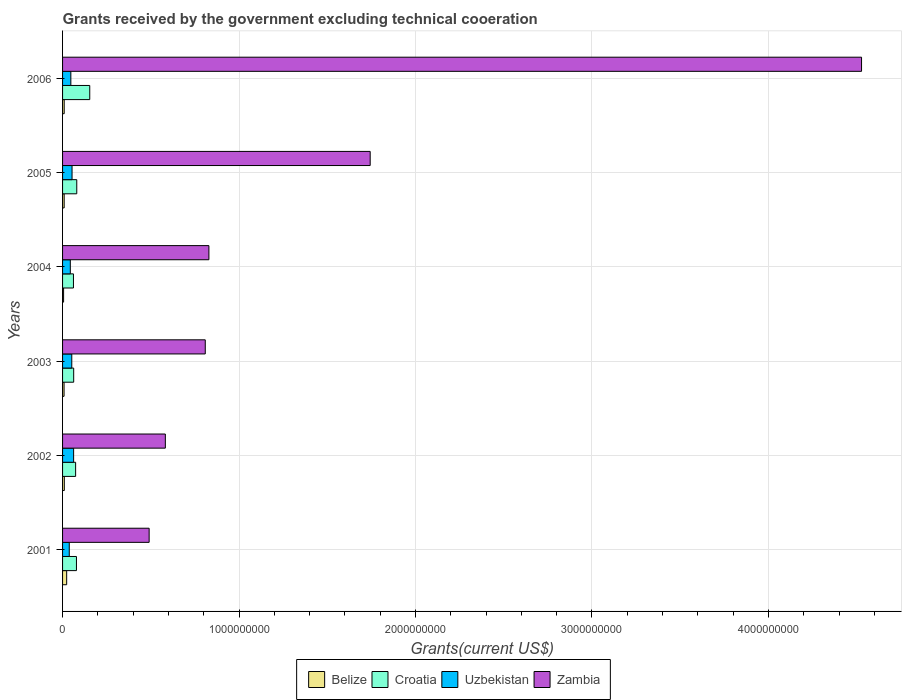In how many cases, is the number of bars for a given year not equal to the number of legend labels?
Your answer should be very brief. 0. What is the total grants received by the government in Belize in 2004?
Your response must be concise. 5.80e+06. Across all years, what is the maximum total grants received by the government in Croatia?
Your response must be concise. 1.54e+08. Across all years, what is the minimum total grants received by the government in Uzbekistan?
Offer a very short reply. 3.80e+07. What is the total total grants received by the government in Belize in the graph?
Offer a very short reply. 6.58e+07. What is the difference between the total grants received by the government in Croatia in 2004 and that in 2005?
Provide a short and direct response. -1.88e+07. What is the difference between the total grants received by the government in Uzbekistan in 2004 and the total grants received by the government in Croatia in 2005?
Make the answer very short. -3.65e+07. What is the average total grants received by the government in Uzbekistan per year?
Your answer should be very brief. 4.96e+07. In the year 2001, what is the difference between the total grants received by the government in Belize and total grants received by the government in Croatia?
Ensure brevity in your answer.  -5.54e+07. In how many years, is the total grants received by the government in Belize greater than 4200000000 US$?
Provide a short and direct response. 0. What is the ratio of the total grants received by the government in Uzbekistan in 2004 to that in 2005?
Your response must be concise. 0.82. Is the total grants received by the government in Uzbekistan in 2001 less than that in 2003?
Provide a short and direct response. Yes. What is the difference between the highest and the second highest total grants received by the government in Croatia?
Ensure brevity in your answer.  7.36e+07. What is the difference between the highest and the lowest total grants received by the government in Croatia?
Provide a succinct answer. 9.24e+07. Is it the case that in every year, the sum of the total grants received by the government in Uzbekistan and total grants received by the government in Zambia is greater than the sum of total grants received by the government in Croatia and total grants received by the government in Belize?
Make the answer very short. Yes. What does the 3rd bar from the top in 2006 represents?
Provide a short and direct response. Croatia. What does the 3rd bar from the bottom in 2006 represents?
Make the answer very short. Uzbekistan. Is it the case that in every year, the sum of the total grants received by the government in Croatia and total grants received by the government in Uzbekistan is greater than the total grants received by the government in Belize?
Offer a terse response. Yes. How many bars are there?
Keep it short and to the point. 24. Are all the bars in the graph horizontal?
Keep it short and to the point. Yes. What is the difference between two consecutive major ticks on the X-axis?
Keep it short and to the point. 1.00e+09. Does the graph contain any zero values?
Provide a succinct answer. No. Does the graph contain grids?
Keep it short and to the point. Yes. How many legend labels are there?
Make the answer very short. 4. How are the legend labels stacked?
Your answer should be compact. Horizontal. What is the title of the graph?
Ensure brevity in your answer.  Grants received by the government excluding technical cooeration. Does "Gambia, The" appear as one of the legend labels in the graph?
Offer a terse response. No. What is the label or title of the X-axis?
Give a very brief answer. Grants(current US$). What is the Grants(current US$) of Belize in 2001?
Ensure brevity in your answer.  2.33e+07. What is the Grants(current US$) in Croatia in 2001?
Your response must be concise. 7.87e+07. What is the Grants(current US$) in Uzbekistan in 2001?
Keep it short and to the point. 3.80e+07. What is the Grants(current US$) of Zambia in 2001?
Offer a very short reply. 4.91e+08. What is the Grants(current US$) of Belize in 2002?
Make the answer very short. 9.91e+06. What is the Grants(current US$) of Croatia in 2002?
Provide a short and direct response. 7.40e+07. What is the Grants(current US$) of Uzbekistan in 2002?
Your answer should be compact. 6.26e+07. What is the Grants(current US$) of Zambia in 2002?
Your answer should be very brief. 5.82e+08. What is the Grants(current US$) in Belize in 2003?
Provide a short and direct response. 8.45e+06. What is the Grants(current US$) of Croatia in 2003?
Give a very brief answer. 6.30e+07. What is the Grants(current US$) of Uzbekistan in 2003?
Offer a very short reply. 5.22e+07. What is the Grants(current US$) in Zambia in 2003?
Provide a short and direct response. 8.09e+08. What is the Grants(current US$) of Belize in 2004?
Provide a succinct answer. 5.80e+06. What is the Grants(current US$) in Croatia in 2004?
Give a very brief answer. 6.17e+07. What is the Grants(current US$) of Uzbekistan in 2004?
Offer a very short reply. 4.39e+07. What is the Grants(current US$) in Zambia in 2004?
Provide a succinct answer. 8.29e+08. What is the Grants(current US$) of Belize in 2005?
Provide a short and direct response. 9.09e+06. What is the Grants(current US$) of Croatia in 2005?
Provide a short and direct response. 8.04e+07. What is the Grants(current US$) in Uzbekistan in 2005?
Provide a short and direct response. 5.37e+07. What is the Grants(current US$) in Zambia in 2005?
Your response must be concise. 1.74e+09. What is the Grants(current US$) in Belize in 2006?
Make the answer very short. 9.27e+06. What is the Grants(current US$) of Croatia in 2006?
Give a very brief answer. 1.54e+08. What is the Grants(current US$) of Uzbekistan in 2006?
Your response must be concise. 4.69e+07. What is the Grants(current US$) of Zambia in 2006?
Offer a very short reply. 4.53e+09. Across all years, what is the maximum Grants(current US$) in Belize?
Offer a terse response. 2.33e+07. Across all years, what is the maximum Grants(current US$) of Croatia?
Keep it short and to the point. 1.54e+08. Across all years, what is the maximum Grants(current US$) in Uzbekistan?
Keep it short and to the point. 6.26e+07. Across all years, what is the maximum Grants(current US$) of Zambia?
Your response must be concise. 4.53e+09. Across all years, what is the minimum Grants(current US$) of Belize?
Provide a succinct answer. 5.80e+06. Across all years, what is the minimum Grants(current US$) of Croatia?
Ensure brevity in your answer.  6.17e+07. Across all years, what is the minimum Grants(current US$) of Uzbekistan?
Your answer should be compact. 3.80e+07. Across all years, what is the minimum Grants(current US$) of Zambia?
Ensure brevity in your answer.  4.91e+08. What is the total Grants(current US$) of Belize in the graph?
Your answer should be very brief. 6.58e+07. What is the total Grants(current US$) of Croatia in the graph?
Ensure brevity in your answer.  5.12e+08. What is the total Grants(current US$) in Uzbekistan in the graph?
Your answer should be compact. 2.97e+08. What is the total Grants(current US$) of Zambia in the graph?
Offer a terse response. 8.98e+09. What is the difference between the Grants(current US$) of Belize in 2001 and that in 2002?
Your answer should be very brief. 1.34e+07. What is the difference between the Grants(current US$) in Croatia in 2001 and that in 2002?
Offer a terse response. 4.76e+06. What is the difference between the Grants(current US$) in Uzbekistan in 2001 and that in 2002?
Make the answer very short. -2.46e+07. What is the difference between the Grants(current US$) of Zambia in 2001 and that in 2002?
Offer a very short reply. -9.18e+07. What is the difference between the Grants(current US$) of Belize in 2001 and that in 2003?
Offer a terse response. 1.48e+07. What is the difference between the Grants(current US$) in Croatia in 2001 and that in 2003?
Your response must be concise. 1.58e+07. What is the difference between the Grants(current US$) in Uzbekistan in 2001 and that in 2003?
Provide a succinct answer. -1.42e+07. What is the difference between the Grants(current US$) of Zambia in 2001 and that in 2003?
Your answer should be very brief. -3.18e+08. What is the difference between the Grants(current US$) of Belize in 2001 and that in 2004?
Make the answer very short. 1.75e+07. What is the difference between the Grants(current US$) of Croatia in 2001 and that in 2004?
Ensure brevity in your answer.  1.71e+07. What is the difference between the Grants(current US$) of Uzbekistan in 2001 and that in 2004?
Keep it short and to the point. -5.89e+06. What is the difference between the Grants(current US$) of Zambia in 2001 and that in 2004?
Your response must be concise. -3.39e+08. What is the difference between the Grants(current US$) in Belize in 2001 and that in 2005?
Ensure brevity in your answer.  1.42e+07. What is the difference between the Grants(current US$) of Croatia in 2001 and that in 2005?
Your response must be concise. -1.70e+06. What is the difference between the Grants(current US$) in Uzbekistan in 2001 and that in 2005?
Give a very brief answer. -1.57e+07. What is the difference between the Grants(current US$) in Zambia in 2001 and that in 2005?
Offer a very short reply. -1.25e+09. What is the difference between the Grants(current US$) of Belize in 2001 and that in 2006?
Offer a very short reply. 1.40e+07. What is the difference between the Grants(current US$) in Croatia in 2001 and that in 2006?
Provide a short and direct response. -7.53e+07. What is the difference between the Grants(current US$) of Uzbekistan in 2001 and that in 2006?
Make the answer very short. -8.90e+06. What is the difference between the Grants(current US$) in Zambia in 2001 and that in 2006?
Ensure brevity in your answer.  -4.04e+09. What is the difference between the Grants(current US$) in Belize in 2002 and that in 2003?
Make the answer very short. 1.46e+06. What is the difference between the Grants(current US$) in Croatia in 2002 and that in 2003?
Your answer should be compact. 1.10e+07. What is the difference between the Grants(current US$) in Uzbekistan in 2002 and that in 2003?
Your answer should be very brief. 1.04e+07. What is the difference between the Grants(current US$) of Zambia in 2002 and that in 2003?
Offer a very short reply. -2.26e+08. What is the difference between the Grants(current US$) of Belize in 2002 and that in 2004?
Your answer should be compact. 4.11e+06. What is the difference between the Grants(current US$) of Croatia in 2002 and that in 2004?
Keep it short and to the point. 1.23e+07. What is the difference between the Grants(current US$) of Uzbekistan in 2002 and that in 2004?
Provide a succinct answer. 1.88e+07. What is the difference between the Grants(current US$) in Zambia in 2002 and that in 2004?
Your answer should be compact. -2.47e+08. What is the difference between the Grants(current US$) in Belize in 2002 and that in 2005?
Provide a short and direct response. 8.20e+05. What is the difference between the Grants(current US$) in Croatia in 2002 and that in 2005?
Your answer should be compact. -6.46e+06. What is the difference between the Grants(current US$) in Uzbekistan in 2002 and that in 2005?
Your answer should be very brief. 8.91e+06. What is the difference between the Grants(current US$) in Zambia in 2002 and that in 2005?
Give a very brief answer. -1.16e+09. What is the difference between the Grants(current US$) in Belize in 2002 and that in 2006?
Provide a short and direct response. 6.40e+05. What is the difference between the Grants(current US$) in Croatia in 2002 and that in 2006?
Give a very brief answer. -8.01e+07. What is the difference between the Grants(current US$) in Uzbekistan in 2002 and that in 2006?
Offer a very short reply. 1.57e+07. What is the difference between the Grants(current US$) in Zambia in 2002 and that in 2006?
Give a very brief answer. -3.94e+09. What is the difference between the Grants(current US$) in Belize in 2003 and that in 2004?
Your response must be concise. 2.65e+06. What is the difference between the Grants(current US$) of Croatia in 2003 and that in 2004?
Your answer should be compact. 1.32e+06. What is the difference between the Grants(current US$) in Uzbekistan in 2003 and that in 2004?
Offer a very short reply. 8.30e+06. What is the difference between the Grants(current US$) of Zambia in 2003 and that in 2004?
Ensure brevity in your answer.  -2.06e+07. What is the difference between the Grants(current US$) of Belize in 2003 and that in 2005?
Ensure brevity in your answer.  -6.40e+05. What is the difference between the Grants(current US$) of Croatia in 2003 and that in 2005?
Provide a short and direct response. -1.74e+07. What is the difference between the Grants(current US$) in Uzbekistan in 2003 and that in 2005?
Your answer should be very brief. -1.54e+06. What is the difference between the Grants(current US$) of Zambia in 2003 and that in 2005?
Give a very brief answer. -9.34e+08. What is the difference between the Grants(current US$) in Belize in 2003 and that in 2006?
Provide a short and direct response. -8.20e+05. What is the difference between the Grants(current US$) in Croatia in 2003 and that in 2006?
Your answer should be very brief. -9.11e+07. What is the difference between the Grants(current US$) in Uzbekistan in 2003 and that in 2006?
Give a very brief answer. 5.29e+06. What is the difference between the Grants(current US$) in Zambia in 2003 and that in 2006?
Give a very brief answer. -3.72e+09. What is the difference between the Grants(current US$) in Belize in 2004 and that in 2005?
Make the answer very short. -3.29e+06. What is the difference between the Grants(current US$) of Croatia in 2004 and that in 2005?
Give a very brief answer. -1.88e+07. What is the difference between the Grants(current US$) of Uzbekistan in 2004 and that in 2005?
Provide a short and direct response. -9.84e+06. What is the difference between the Grants(current US$) of Zambia in 2004 and that in 2005?
Offer a terse response. -9.14e+08. What is the difference between the Grants(current US$) of Belize in 2004 and that in 2006?
Provide a short and direct response. -3.47e+06. What is the difference between the Grants(current US$) of Croatia in 2004 and that in 2006?
Ensure brevity in your answer.  -9.24e+07. What is the difference between the Grants(current US$) in Uzbekistan in 2004 and that in 2006?
Your answer should be very brief. -3.01e+06. What is the difference between the Grants(current US$) in Zambia in 2004 and that in 2006?
Ensure brevity in your answer.  -3.70e+09. What is the difference between the Grants(current US$) of Belize in 2005 and that in 2006?
Give a very brief answer. -1.80e+05. What is the difference between the Grants(current US$) of Croatia in 2005 and that in 2006?
Offer a terse response. -7.36e+07. What is the difference between the Grants(current US$) of Uzbekistan in 2005 and that in 2006?
Provide a short and direct response. 6.83e+06. What is the difference between the Grants(current US$) in Zambia in 2005 and that in 2006?
Make the answer very short. -2.78e+09. What is the difference between the Grants(current US$) of Belize in 2001 and the Grants(current US$) of Croatia in 2002?
Ensure brevity in your answer.  -5.07e+07. What is the difference between the Grants(current US$) of Belize in 2001 and the Grants(current US$) of Uzbekistan in 2002?
Give a very brief answer. -3.94e+07. What is the difference between the Grants(current US$) in Belize in 2001 and the Grants(current US$) in Zambia in 2002?
Your answer should be very brief. -5.59e+08. What is the difference between the Grants(current US$) of Croatia in 2001 and the Grants(current US$) of Uzbekistan in 2002?
Your answer should be compact. 1.61e+07. What is the difference between the Grants(current US$) of Croatia in 2001 and the Grants(current US$) of Zambia in 2002?
Your answer should be compact. -5.04e+08. What is the difference between the Grants(current US$) of Uzbekistan in 2001 and the Grants(current US$) of Zambia in 2002?
Offer a very short reply. -5.44e+08. What is the difference between the Grants(current US$) in Belize in 2001 and the Grants(current US$) in Croatia in 2003?
Make the answer very short. -3.97e+07. What is the difference between the Grants(current US$) of Belize in 2001 and the Grants(current US$) of Uzbekistan in 2003?
Give a very brief answer. -2.89e+07. What is the difference between the Grants(current US$) of Belize in 2001 and the Grants(current US$) of Zambia in 2003?
Keep it short and to the point. -7.85e+08. What is the difference between the Grants(current US$) of Croatia in 2001 and the Grants(current US$) of Uzbekistan in 2003?
Your response must be concise. 2.65e+07. What is the difference between the Grants(current US$) of Croatia in 2001 and the Grants(current US$) of Zambia in 2003?
Provide a succinct answer. -7.30e+08. What is the difference between the Grants(current US$) of Uzbekistan in 2001 and the Grants(current US$) of Zambia in 2003?
Your answer should be compact. -7.71e+08. What is the difference between the Grants(current US$) in Belize in 2001 and the Grants(current US$) in Croatia in 2004?
Make the answer very short. -3.84e+07. What is the difference between the Grants(current US$) of Belize in 2001 and the Grants(current US$) of Uzbekistan in 2004?
Your answer should be very brief. -2.06e+07. What is the difference between the Grants(current US$) in Belize in 2001 and the Grants(current US$) in Zambia in 2004?
Make the answer very short. -8.06e+08. What is the difference between the Grants(current US$) in Croatia in 2001 and the Grants(current US$) in Uzbekistan in 2004?
Offer a terse response. 3.48e+07. What is the difference between the Grants(current US$) in Croatia in 2001 and the Grants(current US$) in Zambia in 2004?
Your answer should be very brief. -7.50e+08. What is the difference between the Grants(current US$) in Uzbekistan in 2001 and the Grants(current US$) in Zambia in 2004?
Your answer should be compact. -7.91e+08. What is the difference between the Grants(current US$) of Belize in 2001 and the Grants(current US$) of Croatia in 2005?
Keep it short and to the point. -5.71e+07. What is the difference between the Grants(current US$) in Belize in 2001 and the Grants(current US$) in Uzbekistan in 2005?
Make the answer very short. -3.04e+07. What is the difference between the Grants(current US$) in Belize in 2001 and the Grants(current US$) in Zambia in 2005?
Offer a terse response. -1.72e+09. What is the difference between the Grants(current US$) in Croatia in 2001 and the Grants(current US$) in Uzbekistan in 2005?
Offer a very short reply. 2.50e+07. What is the difference between the Grants(current US$) in Croatia in 2001 and the Grants(current US$) in Zambia in 2005?
Make the answer very short. -1.66e+09. What is the difference between the Grants(current US$) in Uzbekistan in 2001 and the Grants(current US$) in Zambia in 2005?
Ensure brevity in your answer.  -1.71e+09. What is the difference between the Grants(current US$) of Belize in 2001 and the Grants(current US$) of Croatia in 2006?
Offer a very short reply. -1.31e+08. What is the difference between the Grants(current US$) of Belize in 2001 and the Grants(current US$) of Uzbekistan in 2006?
Ensure brevity in your answer.  -2.36e+07. What is the difference between the Grants(current US$) of Belize in 2001 and the Grants(current US$) of Zambia in 2006?
Ensure brevity in your answer.  -4.50e+09. What is the difference between the Grants(current US$) of Croatia in 2001 and the Grants(current US$) of Uzbekistan in 2006?
Offer a very short reply. 3.18e+07. What is the difference between the Grants(current US$) in Croatia in 2001 and the Grants(current US$) in Zambia in 2006?
Provide a short and direct response. -4.45e+09. What is the difference between the Grants(current US$) of Uzbekistan in 2001 and the Grants(current US$) of Zambia in 2006?
Ensure brevity in your answer.  -4.49e+09. What is the difference between the Grants(current US$) of Belize in 2002 and the Grants(current US$) of Croatia in 2003?
Offer a terse response. -5.31e+07. What is the difference between the Grants(current US$) in Belize in 2002 and the Grants(current US$) in Uzbekistan in 2003?
Offer a very short reply. -4.23e+07. What is the difference between the Grants(current US$) of Belize in 2002 and the Grants(current US$) of Zambia in 2003?
Ensure brevity in your answer.  -7.99e+08. What is the difference between the Grants(current US$) in Croatia in 2002 and the Grants(current US$) in Uzbekistan in 2003?
Offer a very short reply. 2.18e+07. What is the difference between the Grants(current US$) in Croatia in 2002 and the Grants(current US$) in Zambia in 2003?
Make the answer very short. -7.35e+08. What is the difference between the Grants(current US$) of Uzbekistan in 2002 and the Grants(current US$) of Zambia in 2003?
Your answer should be very brief. -7.46e+08. What is the difference between the Grants(current US$) in Belize in 2002 and the Grants(current US$) in Croatia in 2004?
Provide a succinct answer. -5.18e+07. What is the difference between the Grants(current US$) of Belize in 2002 and the Grants(current US$) of Uzbekistan in 2004?
Your answer should be very brief. -3.40e+07. What is the difference between the Grants(current US$) in Belize in 2002 and the Grants(current US$) in Zambia in 2004?
Keep it short and to the point. -8.19e+08. What is the difference between the Grants(current US$) in Croatia in 2002 and the Grants(current US$) in Uzbekistan in 2004?
Offer a terse response. 3.01e+07. What is the difference between the Grants(current US$) in Croatia in 2002 and the Grants(current US$) in Zambia in 2004?
Make the answer very short. -7.55e+08. What is the difference between the Grants(current US$) in Uzbekistan in 2002 and the Grants(current US$) in Zambia in 2004?
Your answer should be very brief. -7.67e+08. What is the difference between the Grants(current US$) in Belize in 2002 and the Grants(current US$) in Croatia in 2005?
Your answer should be very brief. -7.05e+07. What is the difference between the Grants(current US$) in Belize in 2002 and the Grants(current US$) in Uzbekistan in 2005?
Offer a very short reply. -4.38e+07. What is the difference between the Grants(current US$) of Belize in 2002 and the Grants(current US$) of Zambia in 2005?
Your answer should be very brief. -1.73e+09. What is the difference between the Grants(current US$) in Croatia in 2002 and the Grants(current US$) in Uzbekistan in 2005?
Your answer should be very brief. 2.02e+07. What is the difference between the Grants(current US$) of Croatia in 2002 and the Grants(current US$) of Zambia in 2005?
Your answer should be very brief. -1.67e+09. What is the difference between the Grants(current US$) of Uzbekistan in 2002 and the Grants(current US$) of Zambia in 2005?
Offer a terse response. -1.68e+09. What is the difference between the Grants(current US$) in Belize in 2002 and the Grants(current US$) in Croatia in 2006?
Your response must be concise. -1.44e+08. What is the difference between the Grants(current US$) of Belize in 2002 and the Grants(current US$) of Uzbekistan in 2006?
Provide a succinct answer. -3.70e+07. What is the difference between the Grants(current US$) of Belize in 2002 and the Grants(current US$) of Zambia in 2006?
Provide a succinct answer. -4.52e+09. What is the difference between the Grants(current US$) in Croatia in 2002 and the Grants(current US$) in Uzbekistan in 2006?
Your answer should be very brief. 2.71e+07. What is the difference between the Grants(current US$) in Croatia in 2002 and the Grants(current US$) in Zambia in 2006?
Give a very brief answer. -4.45e+09. What is the difference between the Grants(current US$) in Uzbekistan in 2002 and the Grants(current US$) in Zambia in 2006?
Offer a very short reply. -4.46e+09. What is the difference between the Grants(current US$) of Belize in 2003 and the Grants(current US$) of Croatia in 2004?
Your response must be concise. -5.32e+07. What is the difference between the Grants(current US$) in Belize in 2003 and the Grants(current US$) in Uzbekistan in 2004?
Provide a short and direct response. -3.54e+07. What is the difference between the Grants(current US$) of Belize in 2003 and the Grants(current US$) of Zambia in 2004?
Offer a very short reply. -8.21e+08. What is the difference between the Grants(current US$) of Croatia in 2003 and the Grants(current US$) of Uzbekistan in 2004?
Give a very brief answer. 1.91e+07. What is the difference between the Grants(current US$) in Croatia in 2003 and the Grants(current US$) in Zambia in 2004?
Make the answer very short. -7.66e+08. What is the difference between the Grants(current US$) in Uzbekistan in 2003 and the Grants(current US$) in Zambia in 2004?
Offer a very short reply. -7.77e+08. What is the difference between the Grants(current US$) in Belize in 2003 and the Grants(current US$) in Croatia in 2005?
Your answer should be very brief. -7.20e+07. What is the difference between the Grants(current US$) in Belize in 2003 and the Grants(current US$) in Uzbekistan in 2005?
Make the answer very short. -4.53e+07. What is the difference between the Grants(current US$) in Belize in 2003 and the Grants(current US$) in Zambia in 2005?
Your answer should be very brief. -1.73e+09. What is the difference between the Grants(current US$) of Croatia in 2003 and the Grants(current US$) of Uzbekistan in 2005?
Your response must be concise. 9.25e+06. What is the difference between the Grants(current US$) in Croatia in 2003 and the Grants(current US$) in Zambia in 2005?
Give a very brief answer. -1.68e+09. What is the difference between the Grants(current US$) of Uzbekistan in 2003 and the Grants(current US$) of Zambia in 2005?
Keep it short and to the point. -1.69e+09. What is the difference between the Grants(current US$) of Belize in 2003 and the Grants(current US$) of Croatia in 2006?
Make the answer very short. -1.46e+08. What is the difference between the Grants(current US$) of Belize in 2003 and the Grants(current US$) of Uzbekistan in 2006?
Your answer should be very brief. -3.84e+07. What is the difference between the Grants(current US$) of Belize in 2003 and the Grants(current US$) of Zambia in 2006?
Keep it short and to the point. -4.52e+09. What is the difference between the Grants(current US$) of Croatia in 2003 and the Grants(current US$) of Uzbekistan in 2006?
Your response must be concise. 1.61e+07. What is the difference between the Grants(current US$) in Croatia in 2003 and the Grants(current US$) in Zambia in 2006?
Offer a terse response. -4.46e+09. What is the difference between the Grants(current US$) in Uzbekistan in 2003 and the Grants(current US$) in Zambia in 2006?
Make the answer very short. -4.48e+09. What is the difference between the Grants(current US$) of Belize in 2004 and the Grants(current US$) of Croatia in 2005?
Offer a very short reply. -7.46e+07. What is the difference between the Grants(current US$) of Belize in 2004 and the Grants(current US$) of Uzbekistan in 2005?
Provide a short and direct response. -4.79e+07. What is the difference between the Grants(current US$) in Belize in 2004 and the Grants(current US$) in Zambia in 2005?
Ensure brevity in your answer.  -1.74e+09. What is the difference between the Grants(current US$) of Croatia in 2004 and the Grants(current US$) of Uzbekistan in 2005?
Your answer should be compact. 7.93e+06. What is the difference between the Grants(current US$) in Croatia in 2004 and the Grants(current US$) in Zambia in 2005?
Provide a short and direct response. -1.68e+09. What is the difference between the Grants(current US$) in Uzbekistan in 2004 and the Grants(current US$) in Zambia in 2005?
Your response must be concise. -1.70e+09. What is the difference between the Grants(current US$) of Belize in 2004 and the Grants(current US$) of Croatia in 2006?
Give a very brief answer. -1.48e+08. What is the difference between the Grants(current US$) of Belize in 2004 and the Grants(current US$) of Uzbekistan in 2006?
Offer a very short reply. -4.11e+07. What is the difference between the Grants(current US$) in Belize in 2004 and the Grants(current US$) in Zambia in 2006?
Your answer should be compact. -4.52e+09. What is the difference between the Grants(current US$) in Croatia in 2004 and the Grants(current US$) in Uzbekistan in 2006?
Ensure brevity in your answer.  1.48e+07. What is the difference between the Grants(current US$) of Croatia in 2004 and the Grants(current US$) of Zambia in 2006?
Your answer should be compact. -4.47e+09. What is the difference between the Grants(current US$) of Uzbekistan in 2004 and the Grants(current US$) of Zambia in 2006?
Offer a very short reply. -4.48e+09. What is the difference between the Grants(current US$) of Belize in 2005 and the Grants(current US$) of Croatia in 2006?
Make the answer very short. -1.45e+08. What is the difference between the Grants(current US$) of Belize in 2005 and the Grants(current US$) of Uzbekistan in 2006?
Ensure brevity in your answer.  -3.78e+07. What is the difference between the Grants(current US$) in Belize in 2005 and the Grants(current US$) in Zambia in 2006?
Provide a succinct answer. -4.52e+09. What is the difference between the Grants(current US$) of Croatia in 2005 and the Grants(current US$) of Uzbekistan in 2006?
Provide a short and direct response. 3.35e+07. What is the difference between the Grants(current US$) in Croatia in 2005 and the Grants(current US$) in Zambia in 2006?
Give a very brief answer. -4.45e+09. What is the difference between the Grants(current US$) in Uzbekistan in 2005 and the Grants(current US$) in Zambia in 2006?
Offer a terse response. -4.47e+09. What is the average Grants(current US$) in Belize per year?
Give a very brief answer. 1.10e+07. What is the average Grants(current US$) of Croatia per year?
Provide a succinct answer. 8.53e+07. What is the average Grants(current US$) of Uzbekistan per year?
Offer a terse response. 4.96e+07. What is the average Grants(current US$) in Zambia per year?
Offer a terse response. 1.50e+09. In the year 2001, what is the difference between the Grants(current US$) in Belize and Grants(current US$) in Croatia?
Provide a succinct answer. -5.54e+07. In the year 2001, what is the difference between the Grants(current US$) in Belize and Grants(current US$) in Uzbekistan?
Offer a terse response. -1.47e+07. In the year 2001, what is the difference between the Grants(current US$) in Belize and Grants(current US$) in Zambia?
Keep it short and to the point. -4.67e+08. In the year 2001, what is the difference between the Grants(current US$) in Croatia and Grants(current US$) in Uzbekistan?
Your response must be concise. 4.07e+07. In the year 2001, what is the difference between the Grants(current US$) in Croatia and Grants(current US$) in Zambia?
Make the answer very short. -4.12e+08. In the year 2001, what is the difference between the Grants(current US$) of Uzbekistan and Grants(current US$) of Zambia?
Your answer should be very brief. -4.53e+08. In the year 2002, what is the difference between the Grants(current US$) in Belize and Grants(current US$) in Croatia?
Make the answer very short. -6.41e+07. In the year 2002, what is the difference between the Grants(current US$) of Belize and Grants(current US$) of Uzbekistan?
Make the answer very short. -5.27e+07. In the year 2002, what is the difference between the Grants(current US$) of Belize and Grants(current US$) of Zambia?
Give a very brief answer. -5.73e+08. In the year 2002, what is the difference between the Grants(current US$) of Croatia and Grants(current US$) of Uzbekistan?
Your answer should be very brief. 1.13e+07. In the year 2002, what is the difference between the Grants(current US$) of Croatia and Grants(current US$) of Zambia?
Provide a short and direct response. -5.08e+08. In the year 2002, what is the difference between the Grants(current US$) of Uzbekistan and Grants(current US$) of Zambia?
Give a very brief answer. -5.20e+08. In the year 2003, what is the difference between the Grants(current US$) of Belize and Grants(current US$) of Croatia?
Your answer should be compact. -5.45e+07. In the year 2003, what is the difference between the Grants(current US$) in Belize and Grants(current US$) in Uzbekistan?
Your answer should be compact. -4.37e+07. In the year 2003, what is the difference between the Grants(current US$) in Belize and Grants(current US$) in Zambia?
Ensure brevity in your answer.  -8.00e+08. In the year 2003, what is the difference between the Grants(current US$) in Croatia and Grants(current US$) in Uzbekistan?
Your answer should be very brief. 1.08e+07. In the year 2003, what is the difference between the Grants(current US$) of Croatia and Grants(current US$) of Zambia?
Provide a short and direct response. -7.46e+08. In the year 2003, what is the difference between the Grants(current US$) in Uzbekistan and Grants(current US$) in Zambia?
Ensure brevity in your answer.  -7.56e+08. In the year 2004, what is the difference between the Grants(current US$) of Belize and Grants(current US$) of Croatia?
Your answer should be very brief. -5.59e+07. In the year 2004, what is the difference between the Grants(current US$) in Belize and Grants(current US$) in Uzbekistan?
Offer a very short reply. -3.81e+07. In the year 2004, what is the difference between the Grants(current US$) in Belize and Grants(current US$) in Zambia?
Ensure brevity in your answer.  -8.23e+08. In the year 2004, what is the difference between the Grants(current US$) in Croatia and Grants(current US$) in Uzbekistan?
Ensure brevity in your answer.  1.78e+07. In the year 2004, what is the difference between the Grants(current US$) of Croatia and Grants(current US$) of Zambia?
Your answer should be compact. -7.68e+08. In the year 2004, what is the difference between the Grants(current US$) in Uzbekistan and Grants(current US$) in Zambia?
Your answer should be compact. -7.85e+08. In the year 2005, what is the difference between the Grants(current US$) of Belize and Grants(current US$) of Croatia?
Ensure brevity in your answer.  -7.13e+07. In the year 2005, what is the difference between the Grants(current US$) in Belize and Grants(current US$) in Uzbekistan?
Provide a short and direct response. -4.46e+07. In the year 2005, what is the difference between the Grants(current US$) of Belize and Grants(current US$) of Zambia?
Make the answer very short. -1.73e+09. In the year 2005, what is the difference between the Grants(current US$) in Croatia and Grants(current US$) in Uzbekistan?
Your answer should be very brief. 2.67e+07. In the year 2005, what is the difference between the Grants(current US$) in Croatia and Grants(current US$) in Zambia?
Your response must be concise. -1.66e+09. In the year 2005, what is the difference between the Grants(current US$) of Uzbekistan and Grants(current US$) of Zambia?
Your response must be concise. -1.69e+09. In the year 2006, what is the difference between the Grants(current US$) in Belize and Grants(current US$) in Croatia?
Ensure brevity in your answer.  -1.45e+08. In the year 2006, what is the difference between the Grants(current US$) of Belize and Grants(current US$) of Uzbekistan?
Offer a terse response. -3.76e+07. In the year 2006, what is the difference between the Grants(current US$) in Belize and Grants(current US$) in Zambia?
Provide a succinct answer. -4.52e+09. In the year 2006, what is the difference between the Grants(current US$) of Croatia and Grants(current US$) of Uzbekistan?
Make the answer very short. 1.07e+08. In the year 2006, what is the difference between the Grants(current US$) of Croatia and Grants(current US$) of Zambia?
Your answer should be compact. -4.37e+09. In the year 2006, what is the difference between the Grants(current US$) in Uzbekistan and Grants(current US$) in Zambia?
Your answer should be very brief. -4.48e+09. What is the ratio of the Grants(current US$) of Belize in 2001 to that in 2002?
Your answer should be very brief. 2.35. What is the ratio of the Grants(current US$) in Croatia in 2001 to that in 2002?
Give a very brief answer. 1.06. What is the ratio of the Grants(current US$) in Uzbekistan in 2001 to that in 2002?
Give a very brief answer. 0.61. What is the ratio of the Grants(current US$) of Zambia in 2001 to that in 2002?
Make the answer very short. 0.84. What is the ratio of the Grants(current US$) in Belize in 2001 to that in 2003?
Provide a short and direct response. 2.76. What is the ratio of the Grants(current US$) in Croatia in 2001 to that in 2003?
Give a very brief answer. 1.25. What is the ratio of the Grants(current US$) of Uzbekistan in 2001 to that in 2003?
Give a very brief answer. 0.73. What is the ratio of the Grants(current US$) of Zambia in 2001 to that in 2003?
Give a very brief answer. 0.61. What is the ratio of the Grants(current US$) of Belize in 2001 to that in 2004?
Keep it short and to the point. 4.02. What is the ratio of the Grants(current US$) of Croatia in 2001 to that in 2004?
Offer a terse response. 1.28. What is the ratio of the Grants(current US$) in Uzbekistan in 2001 to that in 2004?
Make the answer very short. 0.87. What is the ratio of the Grants(current US$) in Zambia in 2001 to that in 2004?
Your answer should be very brief. 0.59. What is the ratio of the Grants(current US$) in Belize in 2001 to that in 2005?
Keep it short and to the point. 2.56. What is the ratio of the Grants(current US$) of Croatia in 2001 to that in 2005?
Provide a short and direct response. 0.98. What is the ratio of the Grants(current US$) in Uzbekistan in 2001 to that in 2005?
Your answer should be very brief. 0.71. What is the ratio of the Grants(current US$) of Zambia in 2001 to that in 2005?
Your answer should be compact. 0.28. What is the ratio of the Grants(current US$) in Belize in 2001 to that in 2006?
Ensure brevity in your answer.  2.51. What is the ratio of the Grants(current US$) in Croatia in 2001 to that in 2006?
Provide a short and direct response. 0.51. What is the ratio of the Grants(current US$) in Uzbekistan in 2001 to that in 2006?
Offer a terse response. 0.81. What is the ratio of the Grants(current US$) of Zambia in 2001 to that in 2006?
Offer a very short reply. 0.11. What is the ratio of the Grants(current US$) in Belize in 2002 to that in 2003?
Your response must be concise. 1.17. What is the ratio of the Grants(current US$) of Croatia in 2002 to that in 2003?
Your answer should be compact. 1.17. What is the ratio of the Grants(current US$) of Uzbekistan in 2002 to that in 2003?
Your answer should be compact. 1.2. What is the ratio of the Grants(current US$) of Zambia in 2002 to that in 2003?
Ensure brevity in your answer.  0.72. What is the ratio of the Grants(current US$) in Belize in 2002 to that in 2004?
Make the answer very short. 1.71. What is the ratio of the Grants(current US$) of Croatia in 2002 to that in 2004?
Your answer should be compact. 1.2. What is the ratio of the Grants(current US$) of Uzbekistan in 2002 to that in 2004?
Offer a terse response. 1.43. What is the ratio of the Grants(current US$) in Zambia in 2002 to that in 2004?
Your response must be concise. 0.7. What is the ratio of the Grants(current US$) of Belize in 2002 to that in 2005?
Provide a succinct answer. 1.09. What is the ratio of the Grants(current US$) in Croatia in 2002 to that in 2005?
Provide a succinct answer. 0.92. What is the ratio of the Grants(current US$) in Uzbekistan in 2002 to that in 2005?
Your answer should be compact. 1.17. What is the ratio of the Grants(current US$) in Zambia in 2002 to that in 2005?
Provide a short and direct response. 0.33. What is the ratio of the Grants(current US$) of Belize in 2002 to that in 2006?
Keep it short and to the point. 1.07. What is the ratio of the Grants(current US$) of Croatia in 2002 to that in 2006?
Your response must be concise. 0.48. What is the ratio of the Grants(current US$) of Uzbekistan in 2002 to that in 2006?
Offer a terse response. 1.34. What is the ratio of the Grants(current US$) in Zambia in 2002 to that in 2006?
Make the answer very short. 0.13. What is the ratio of the Grants(current US$) of Belize in 2003 to that in 2004?
Keep it short and to the point. 1.46. What is the ratio of the Grants(current US$) in Croatia in 2003 to that in 2004?
Your answer should be compact. 1.02. What is the ratio of the Grants(current US$) in Uzbekistan in 2003 to that in 2004?
Keep it short and to the point. 1.19. What is the ratio of the Grants(current US$) of Zambia in 2003 to that in 2004?
Give a very brief answer. 0.98. What is the ratio of the Grants(current US$) in Belize in 2003 to that in 2005?
Offer a terse response. 0.93. What is the ratio of the Grants(current US$) of Croatia in 2003 to that in 2005?
Keep it short and to the point. 0.78. What is the ratio of the Grants(current US$) of Uzbekistan in 2003 to that in 2005?
Your response must be concise. 0.97. What is the ratio of the Grants(current US$) of Zambia in 2003 to that in 2005?
Your response must be concise. 0.46. What is the ratio of the Grants(current US$) in Belize in 2003 to that in 2006?
Your answer should be very brief. 0.91. What is the ratio of the Grants(current US$) of Croatia in 2003 to that in 2006?
Your answer should be very brief. 0.41. What is the ratio of the Grants(current US$) in Uzbekistan in 2003 to that in 2006?
Offer a very short reply. 1.11. What is the ratio of the Grants(current US$) of Zambia in 2003 to that in 2006?
Provide a succinct answer. 0.18. What is the ratio of the Grants(current US$) in Belize in 2004 to that in 2005?
Your answer should be compact. 0.64. What is the ratio of the Grants(current US$) of Croatia in 2004 to that in 2005?
Make the answer very short. 0.77. What is the ratio of the Grants(current US$) in Uzbekistan in 2004 to that in 2005?
Ensure brevity in your answer.  0.82. What is the ratio of the Grants(current US$) of Zambia in 2004 to that in 2005?
Your response must be concise. 0.48. What is the ratio of the Grants(current US$) in Belize in 2004 to that in 2006?
Ensure brevity in your answer.  0.63. What is the ratio of the Grants(current US$) of Croatia in 2004 to that in 2006?
Ensure brevity in your answer.  0.4. What is the ratio of the Grants(current US$) in Uzbekistan in 2004 to that in 2006?
Your answer should be compact. 0.94. What is the ratio of the Grants(current US$) of Zambia in 2004 to that in 2006?
Your answer should be compact. 0.18. What is the ratio of the Grants(current US$) of Belize in 2005 to that in 2006?
Provide a short and direct response. 0.98. What is the ratio of the Grants(current US$) in Croatia in 2005 to that in 2006?
Provide a short and direct response. 0.52. What is the ratio of the Grants(current US$) in Uzbekistan in 2005 to that in 2006?
Your answer should be very brief. 1.15. What is the ratio of the Grants(current US$) in Zambia in 2005 to that in 2006?
Your answer should be compact. 0.39. What is the difference between the highest and the second highest Grants(current US$) in Belize?
Your answer should be very brief. 1.34e+07. What is the difference between the highest and the second highest Grants(current US$) of Croatia?
Your answer should be compact. 7.36e+07. What is the difference between the highest and the second highest Grants(current US$) of Uzbekistan?
Give a very brief answer. 8.91e+06. What is the difference between the highest and the second highest Grants(current US$) of Zambia?
Offer a very short reply. 2.78e+09. What is the difference between the highest and the lowest Grants(current US$) in Belize?
Offer a terse response. 1.75e+07. What is the difference between the highest and the lowest Grants(current US$) of Croatia?
Provide a short and direct response. 9.24e+07. What is the difference between the highest and the lowest Grants(current US$) of Uzbekistan?
Make the answer very short. 2.46e+07. What is the difference between the highest and the lowest Grants(current US$) in Zambia?
Provide a succinct answer. 4.04e+09. 